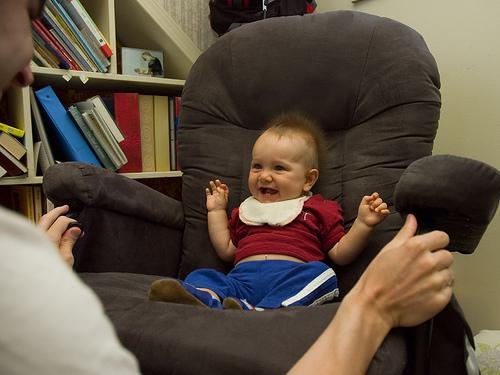Is there a chair in the image? Yes, there is a large, plush chair in the image. It's upholstered in a grey fabric and appears quite comfortable, dominating the scene as it cradles a laughing baby, with an adult's hands playfully encouraging the child from the sides. 